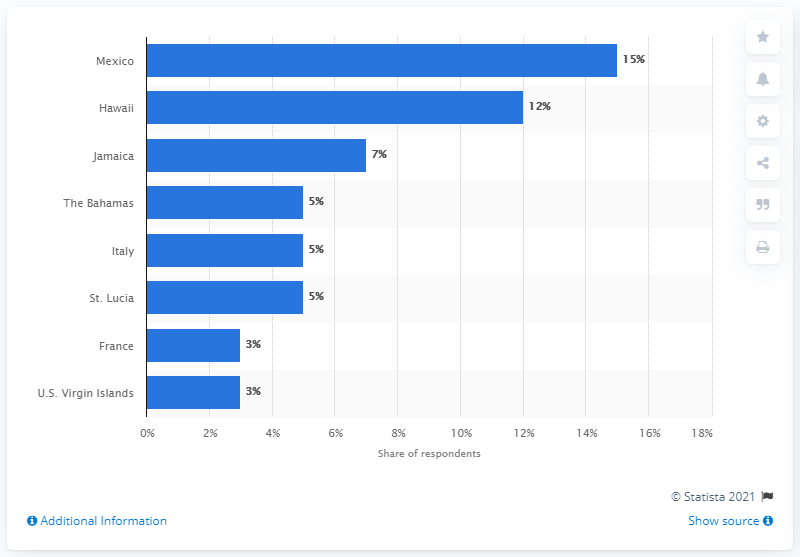Identify some key points in this picture. The most popular honeymoon destination in the United States is Mexico. 